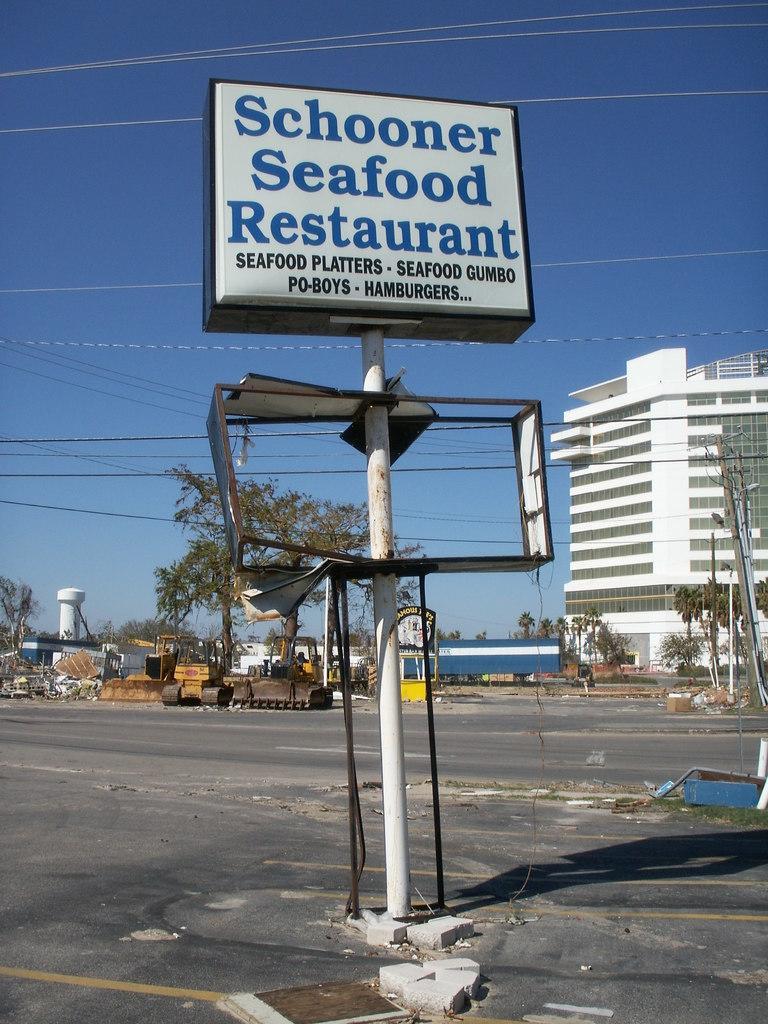In one or two sentences, can you explain what this image depicts? In the background we can see the sky, building, trees, excavators, poles, tower and objects. In this picture we can see a board with some information. At the bottom portion of the picture we can see the road. 